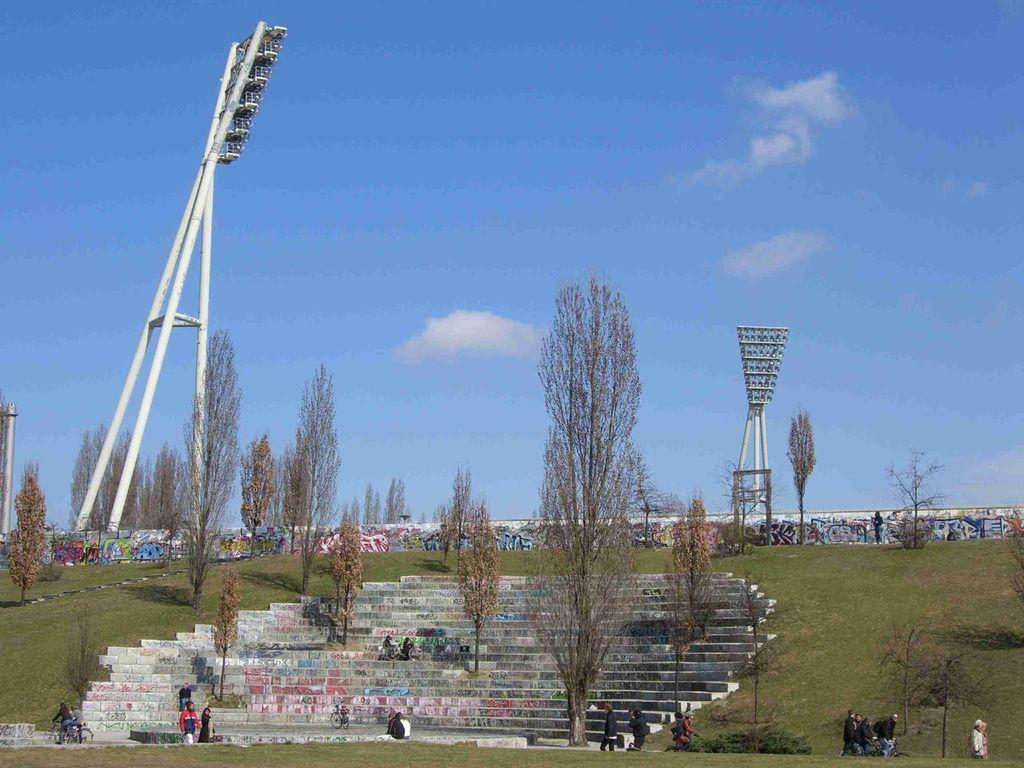What type of vegetation can be seen in the image? There are trees and plants in the image. What architectural feature is present in the image? There are stairs in the image. What type of lighting is present in the image? There are light poles in the image. What type of surface is visible in the image? There is a wall in the image. Who or what is present in the image? There are people in the image. What type of ground cover is visible in the image? There is grass in the image. What type of artwork is present on the wall? There is graffiti on the wall. What part of the natural environment is visible in the background of the image? The sky is visible in the background of the image. Can you see a crib in the image? No, there is no crib present in the image. What type of ship is visible in the image? There is no ship present in the image. 